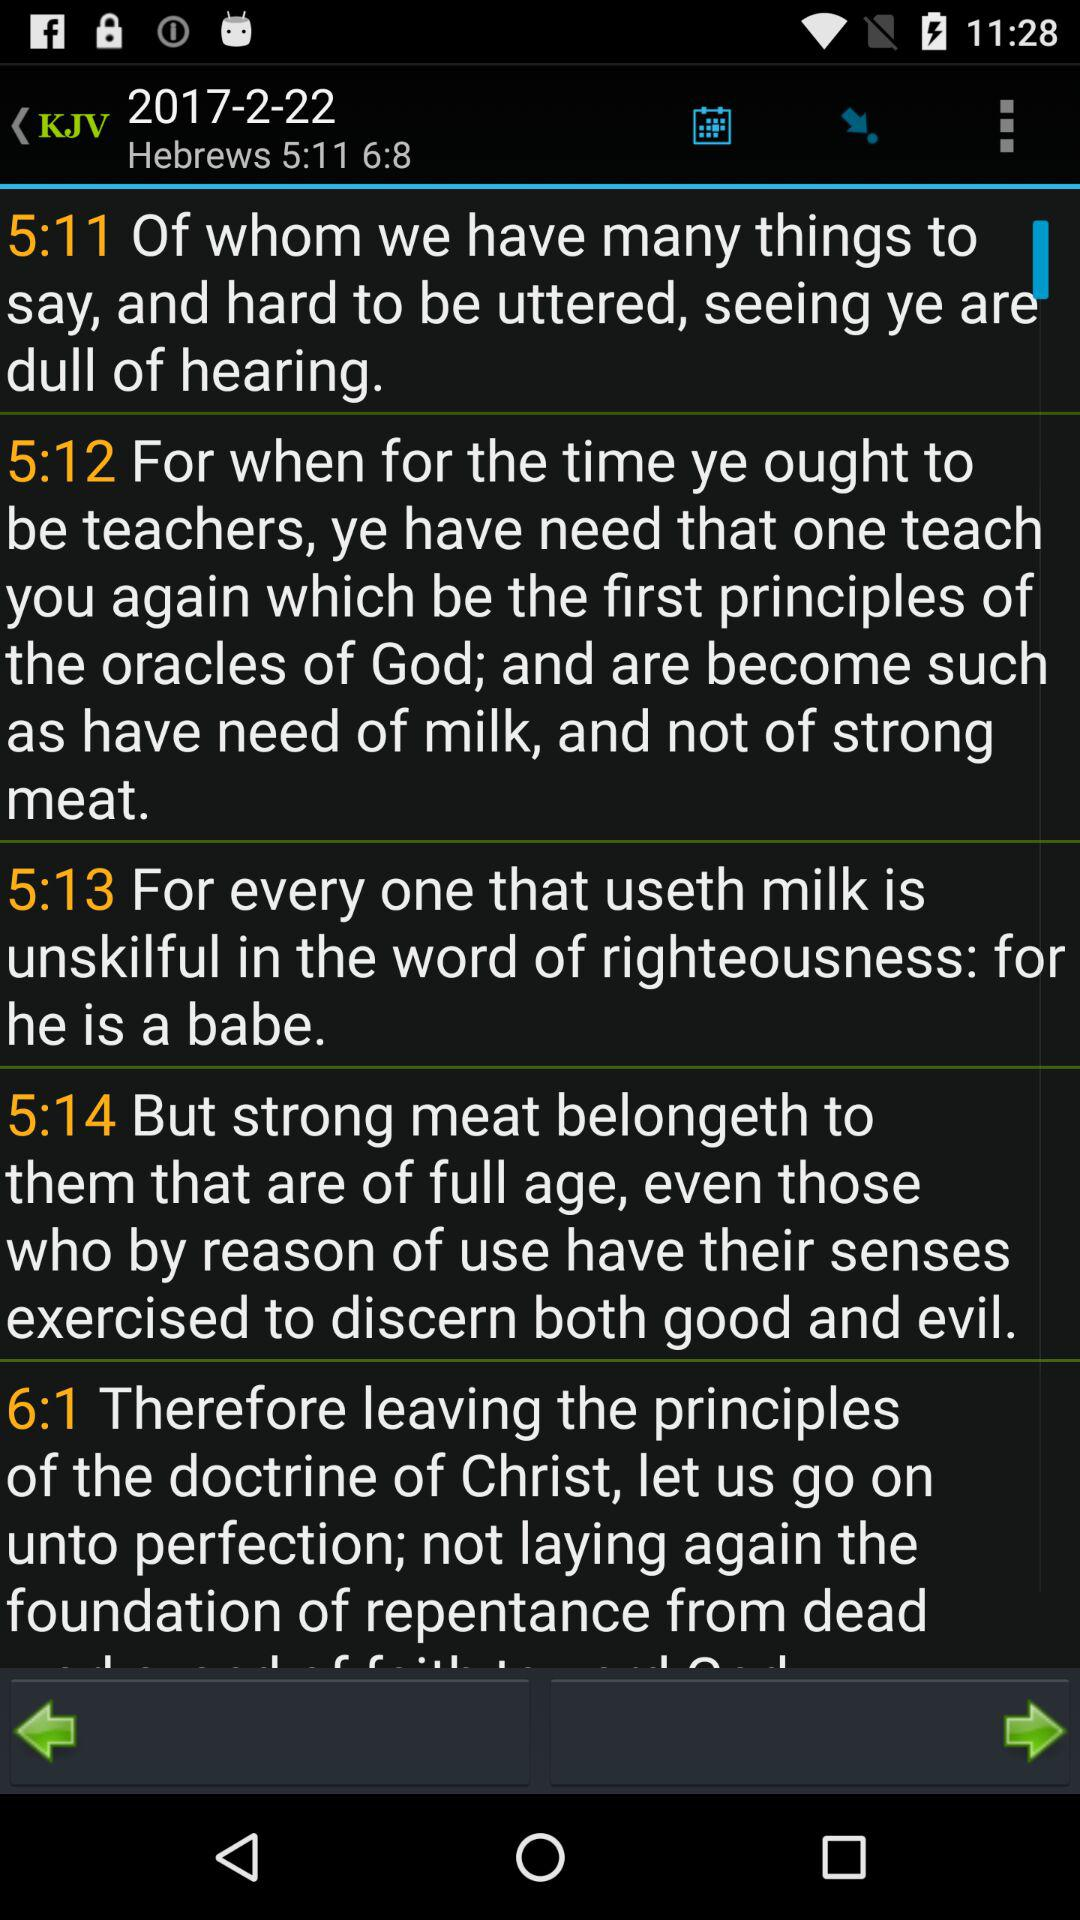What is the mentioned date? The mentioned date is February 22, 2017. 